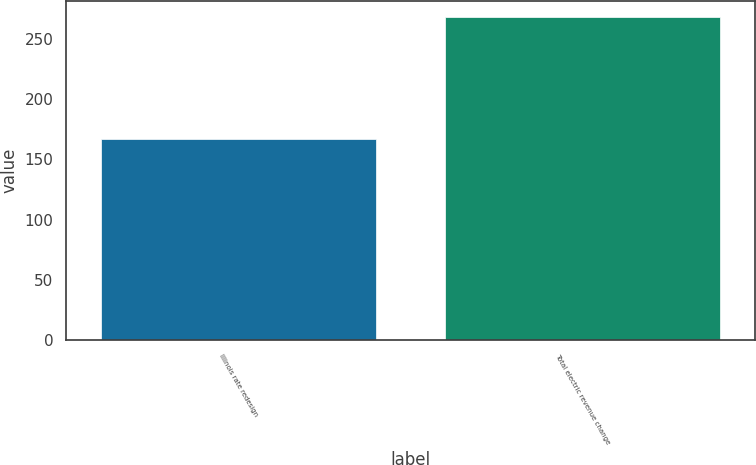Convert chart to OTSL. <chart><loc_0><loc_0><loc_500><loc_500><bar_chart><fcel>Illinois rate redesign<fcel>Total electric revenue change<nl><fcel>167<fcel>268<nl></chart> 